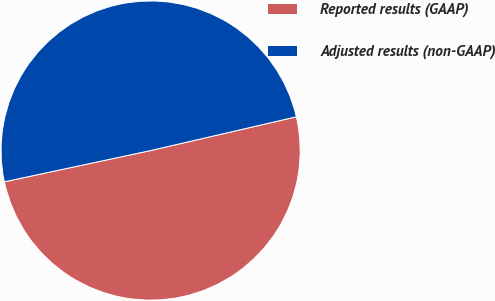<chart> <loc_0><loc_0><loc_500><loc_500><pie_chart><fcel>Reported results (GAAP)<fcel>Adjusted results (non-GAAP)<nl><fcel>50.27%<fcel>49.73%<nl></chart> 